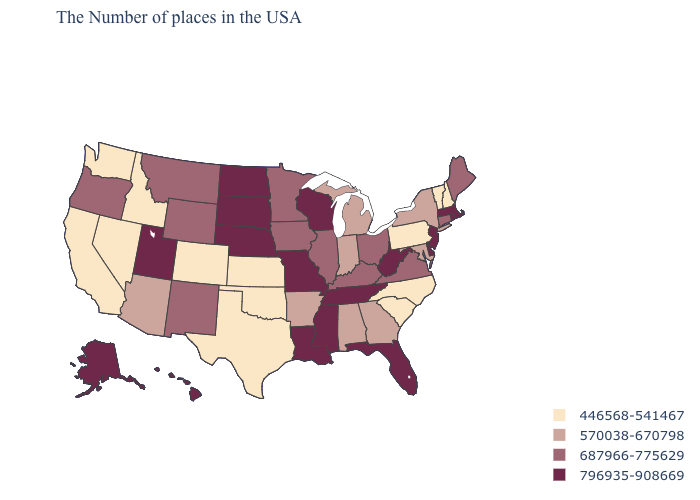Which states have the highest value in the USA?
Write a very short answer. Massachusetts, Rhode Island, New Jersey, Delaware, West Virginia, Florida, Tennessee, Wisconsin, Mississippi, Louisiana, Missouri, Nebraska, South Dakota, North Dakota, Utah, Alaska, Hawaii. Among the states that border Idaho , does Utah have the highest value?
Give a very brief answer. Yes. Name the states that have a value in the range 446568-541467?
Answer briefly. New Hampshire, Vermont, Pennsylvania, North Carolina, South Carolina, Kansas, Oklahoma, Texas, Colorado, Idaho, Nevada, California, Washington. Which states have the highest value in the USA?
Concise answer only. Massachusetts, Rhode Island, New Jersey, Delaware, West Virginia, Florida, Tennessee, Wisconsin, Mississippi, Louisiana, Missouri, Nebraska, South Dakota, North Dakota, Utah, Alaska, Hawaii. Name the states that have a value in the range 687966-775629?
Short answer required. Maine, Connecticut, Virginia, Ohio, Kentucky, Illinois, Minnesota, Iowa, Wyoming, New Mexico, Montana, Oregon. Name the states that have a value in the range 570038-670798?
Short answer required. New York, Maryland, Georgia, Michigan, Indiana, Alabama, Arkansas, Arizona. Name the states that have a value in the range 570038-670798?
Answer briefly. New York, Maryland, Georgia, Michigan, Indiana, Alabama, Arkansas, Arizona. Name the states that have a value in the range 687966-775629?
Concise answer only. Maine, Connecticut, Virginia, Ohio, Kentucky, Illinois, Minnesota, Iowa, Wyoming, New Mexico, Montana, Oregon. What is the value of Idaho?
Be succinct. 446568-541467. What is the value of New York?
Give a very brief answer. 570038-670798. Name the states that have a value in the range 446568-541467?
Keep it brief. New Hampshire, Vermont, Pennsylvania, North Carolina, South Carolina, Kansas, Oklahoma, Texas, Colorado, Idaho, Nevada, California, Washington. Which states have the lowest value in the MidWest?
Give a very brief answer. Kansas. What is the value of New York?
Answer briefly. 570038-670798. Name the states that have a value in the range 446568-541467?
Give a very brief answer. New Hampshire, Vermont, Pennsylvania, North Carolina, South Carolina, Kansas, Oklahoma, Texas, Colorado, Idaho, Nevada, California, Washington. How many symbols are there in the legend?
Keep it brief. 4. 